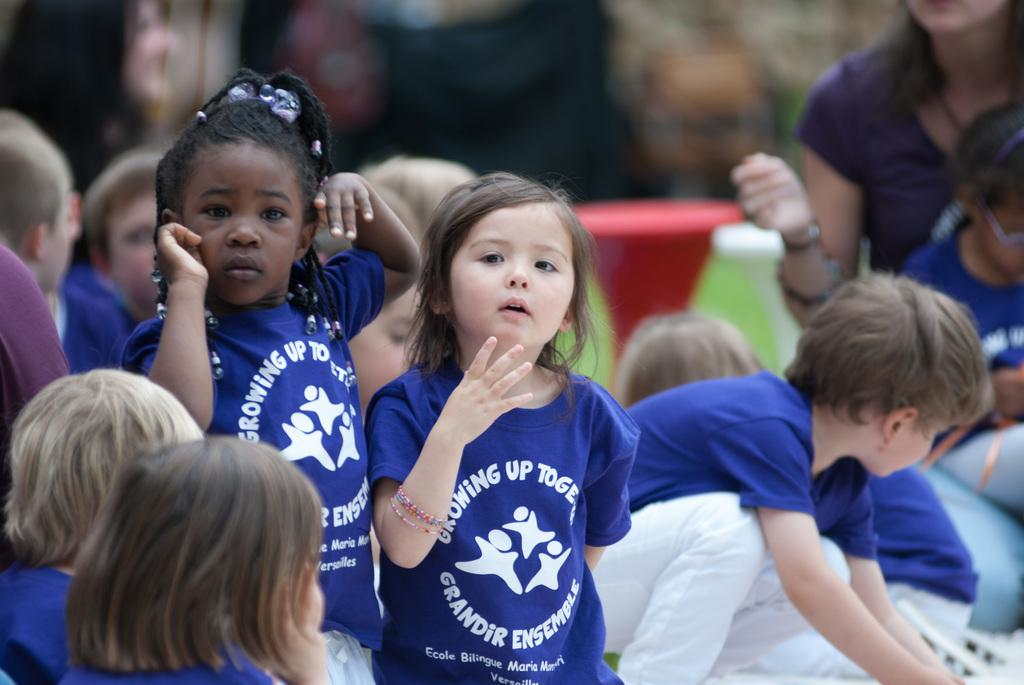Who is present in the image? There are children in the image. What are the children wearing? The children are wearing blue t-shirts. Can you describe the background of the image? The background of the image is blurred. Is there anyone else visible in the image besides the children? Yes, there is a person in the background of the image. What type of veil can be seen on the corn in the image? There is no veil or corn present in the image; it features children wearing blue t-shirts and a person in the background. 